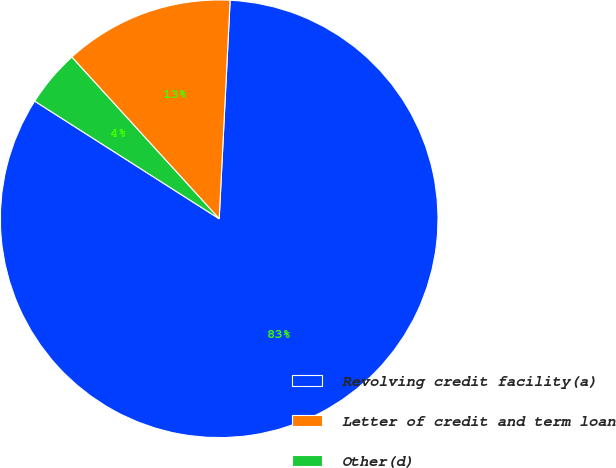<chart> <loc_0><loc_0><loc_500><loc_500><pie_chart><fcel>Revolving credit facility(a)<fcel>Letter of credit and term loan<fcel>Other(d)<nl><fcel>83.24%<fcel>12.56%<fcel>4.2%<nl></chart> 